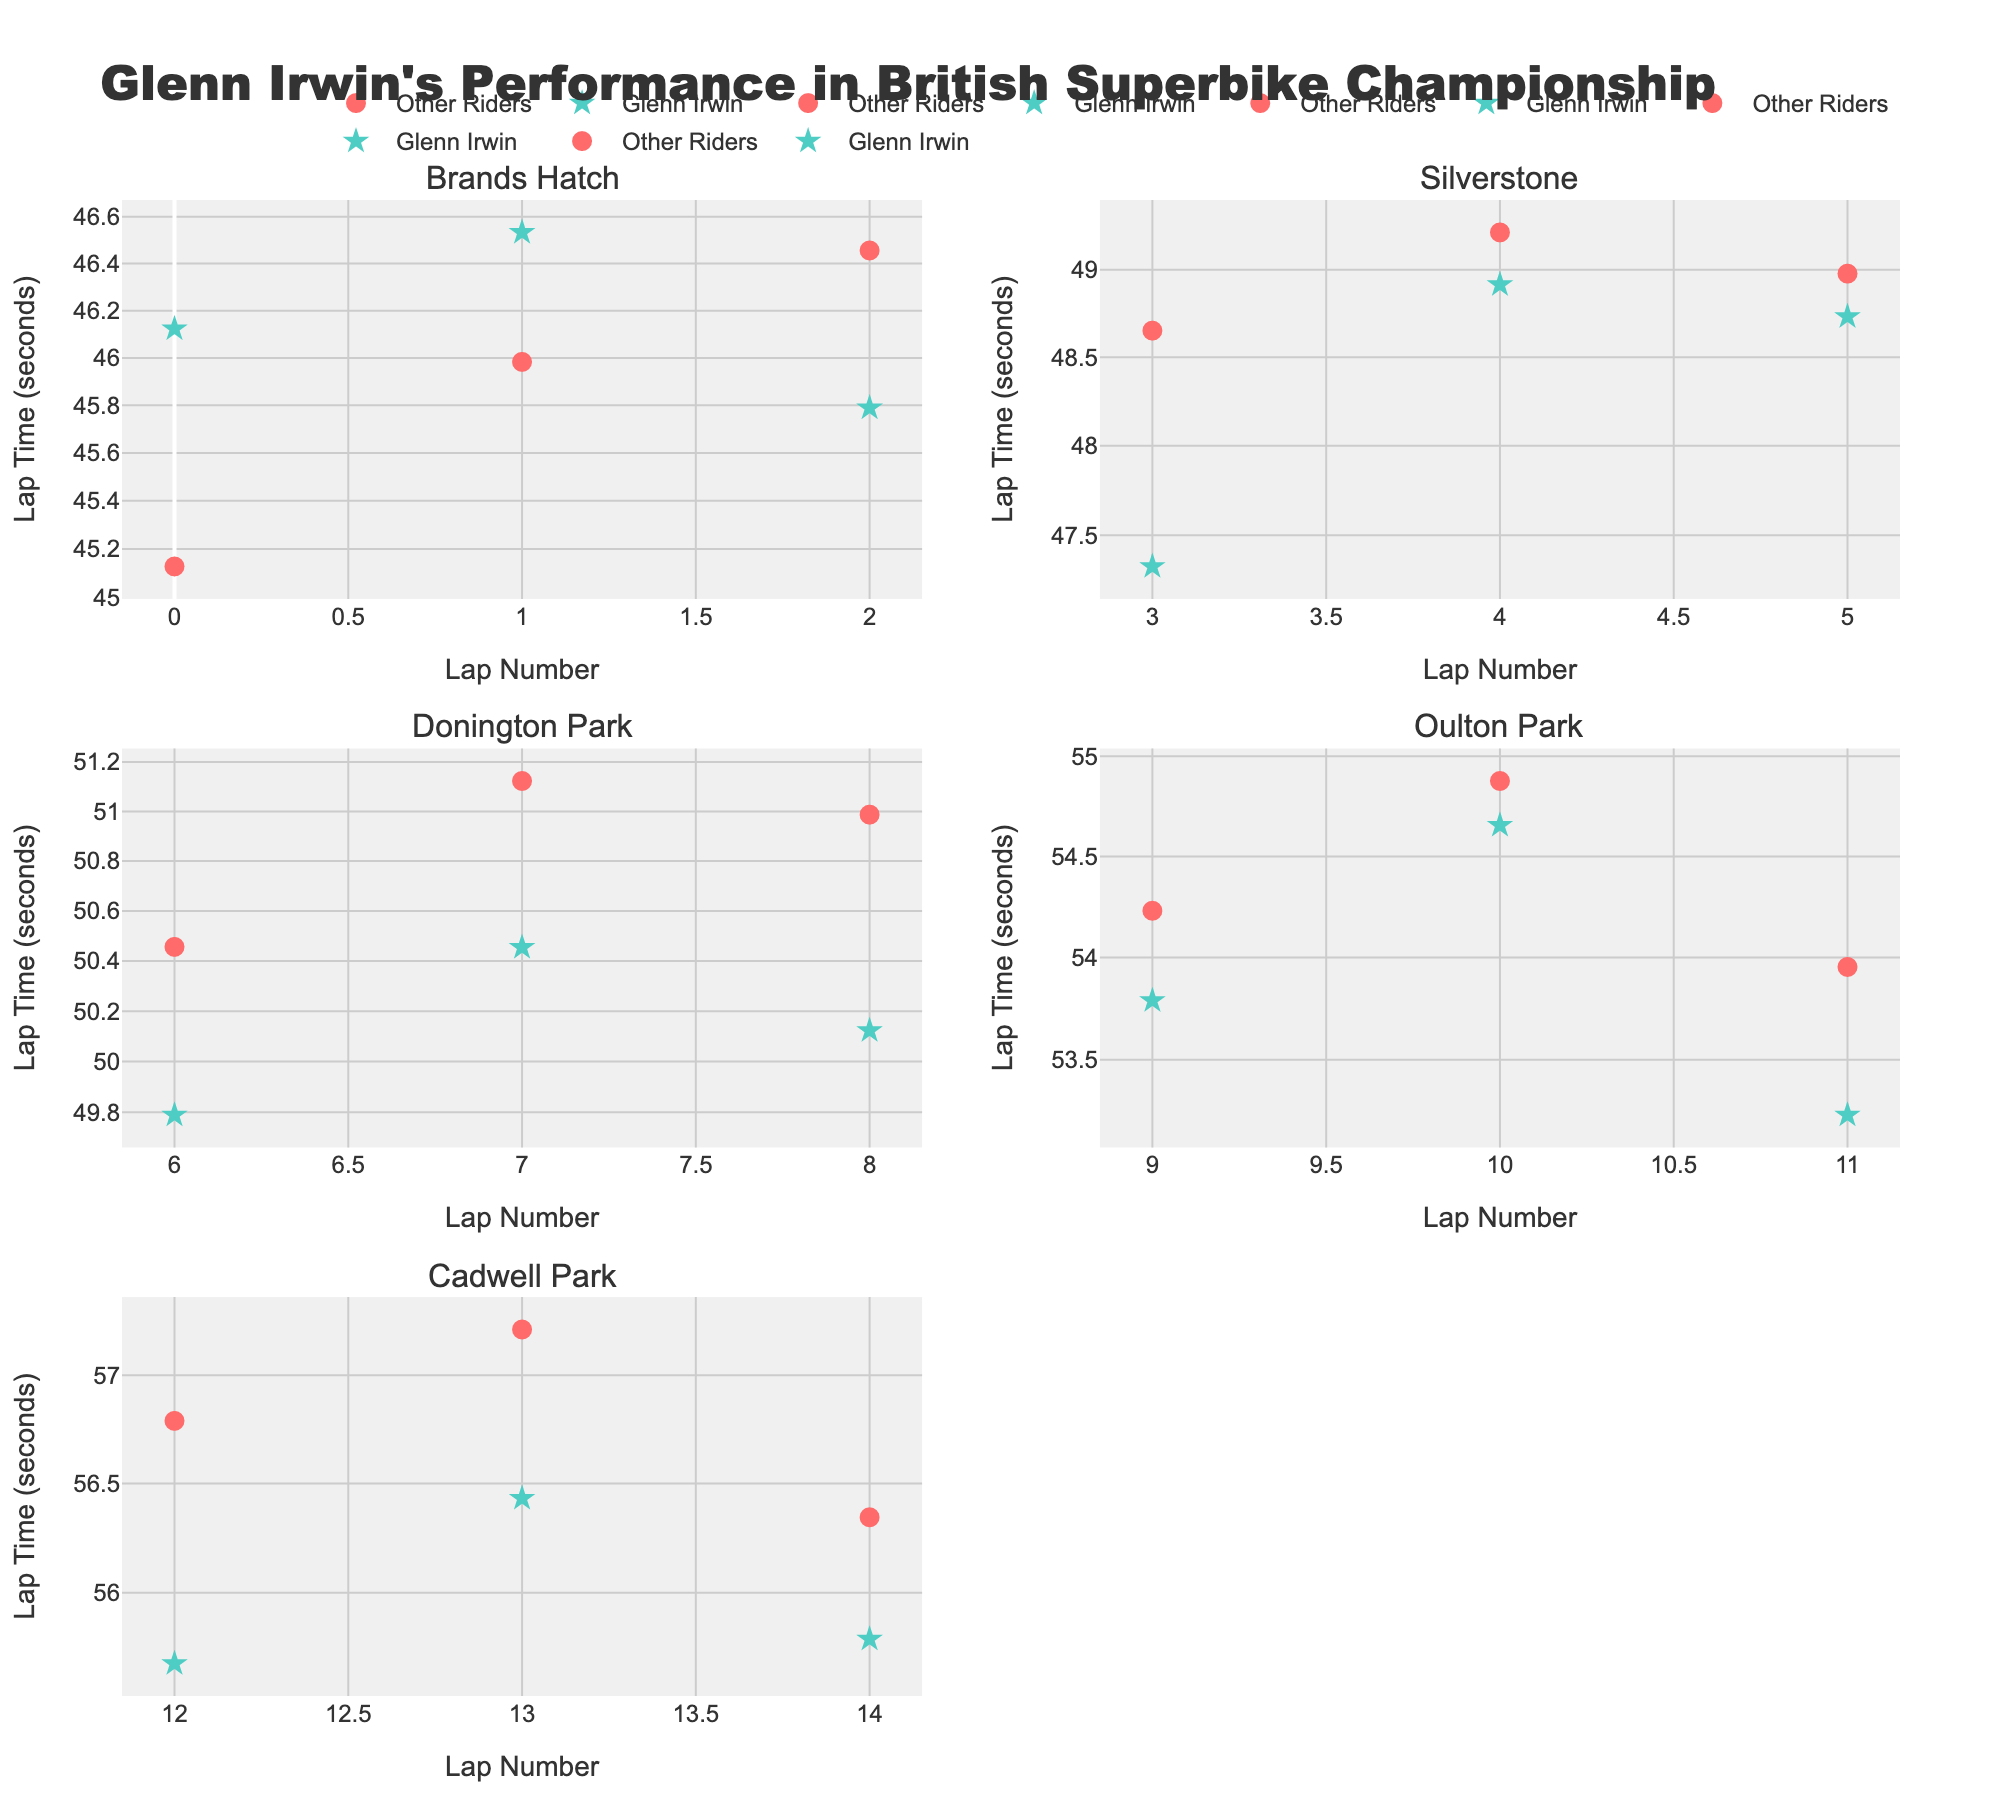what is the title of the figure? The title is found at the top of the figure and summarizes what the plot represents. The title in this case reads "Glenn Irwin's Performance in British Superbike Championship".
Answer: Glenn Irwin's Performance in British Superbike Championship how many subplots are in the figure? The figure's layout is analyzed here, which is divided into several smaller plots representing different circuits. By counting the different segments, we see there are six subplots.
Answer: 6 which subplots have the lowest LapTime for Glenn Irwin? By examining each subplot, we look for the markers representing Glenn Irwin (star symbols) that are plotted lowest on the y-axis (log scale). The circuits with the lowest recorded LapTimes are Brands Hatch and Silverstone.
Answer: Brands Hatch and Silverstone what is the range of LapTimes Glenn Irwin recorded across all circuits? To determine the range, we identify the minimum and maximum LapTimes recorded by Glenn Irwin across all the subplots. The minimum LapTime is found in Brands Hatch (45.789 seconds) and the maximum in Oulton Park (54.655 seconds). The range is calculated as 54.655 - 45.789 = 8.866 seconds.
Answer: 8.866 seconds which circuit had the largest variation in LapTimes for Glenn Irwin? By comparing the difference between the highest and lowest LapTimes in each subplot, we discern that Oulton Park has the largest variation, with a difference between 54.655 and 53.231 seconds, a variation of 1.424 seconds.
Answer: Oulton Park how does Glenn Irwin's performance compare to other riders at Cadwell Park? By observing the stars and circles in the Cadwell Park subplot, we see that Glenn Irwin’s LapTimes (around 55.678, 56.432, and 55.789 seconds) are consistently lower (better) than those of other riders (56.789, 57.213, 56.345 seconds).
Answer: Better which subplot shows Glenn Irwin as consistently faster than other riders? In the Brands Hatch subplot, Glenn Irwin's markers (46.123, 46.533, 45.789 seconds) are consistently lower (better) compared to other riders of the same circuit.
Answer: Brands Hatch in which circuits did Glenn Irwin have all LapTimes lower than the recorded LapTime of all other riders? By checking each subplot where all of Glenn Irwin's LapTimes markers appear lower than the highest LapTime of other riders, we can infer that Brands Hatch and Silverstone have this property.
Answer: Brands Hatch and Silverstone 